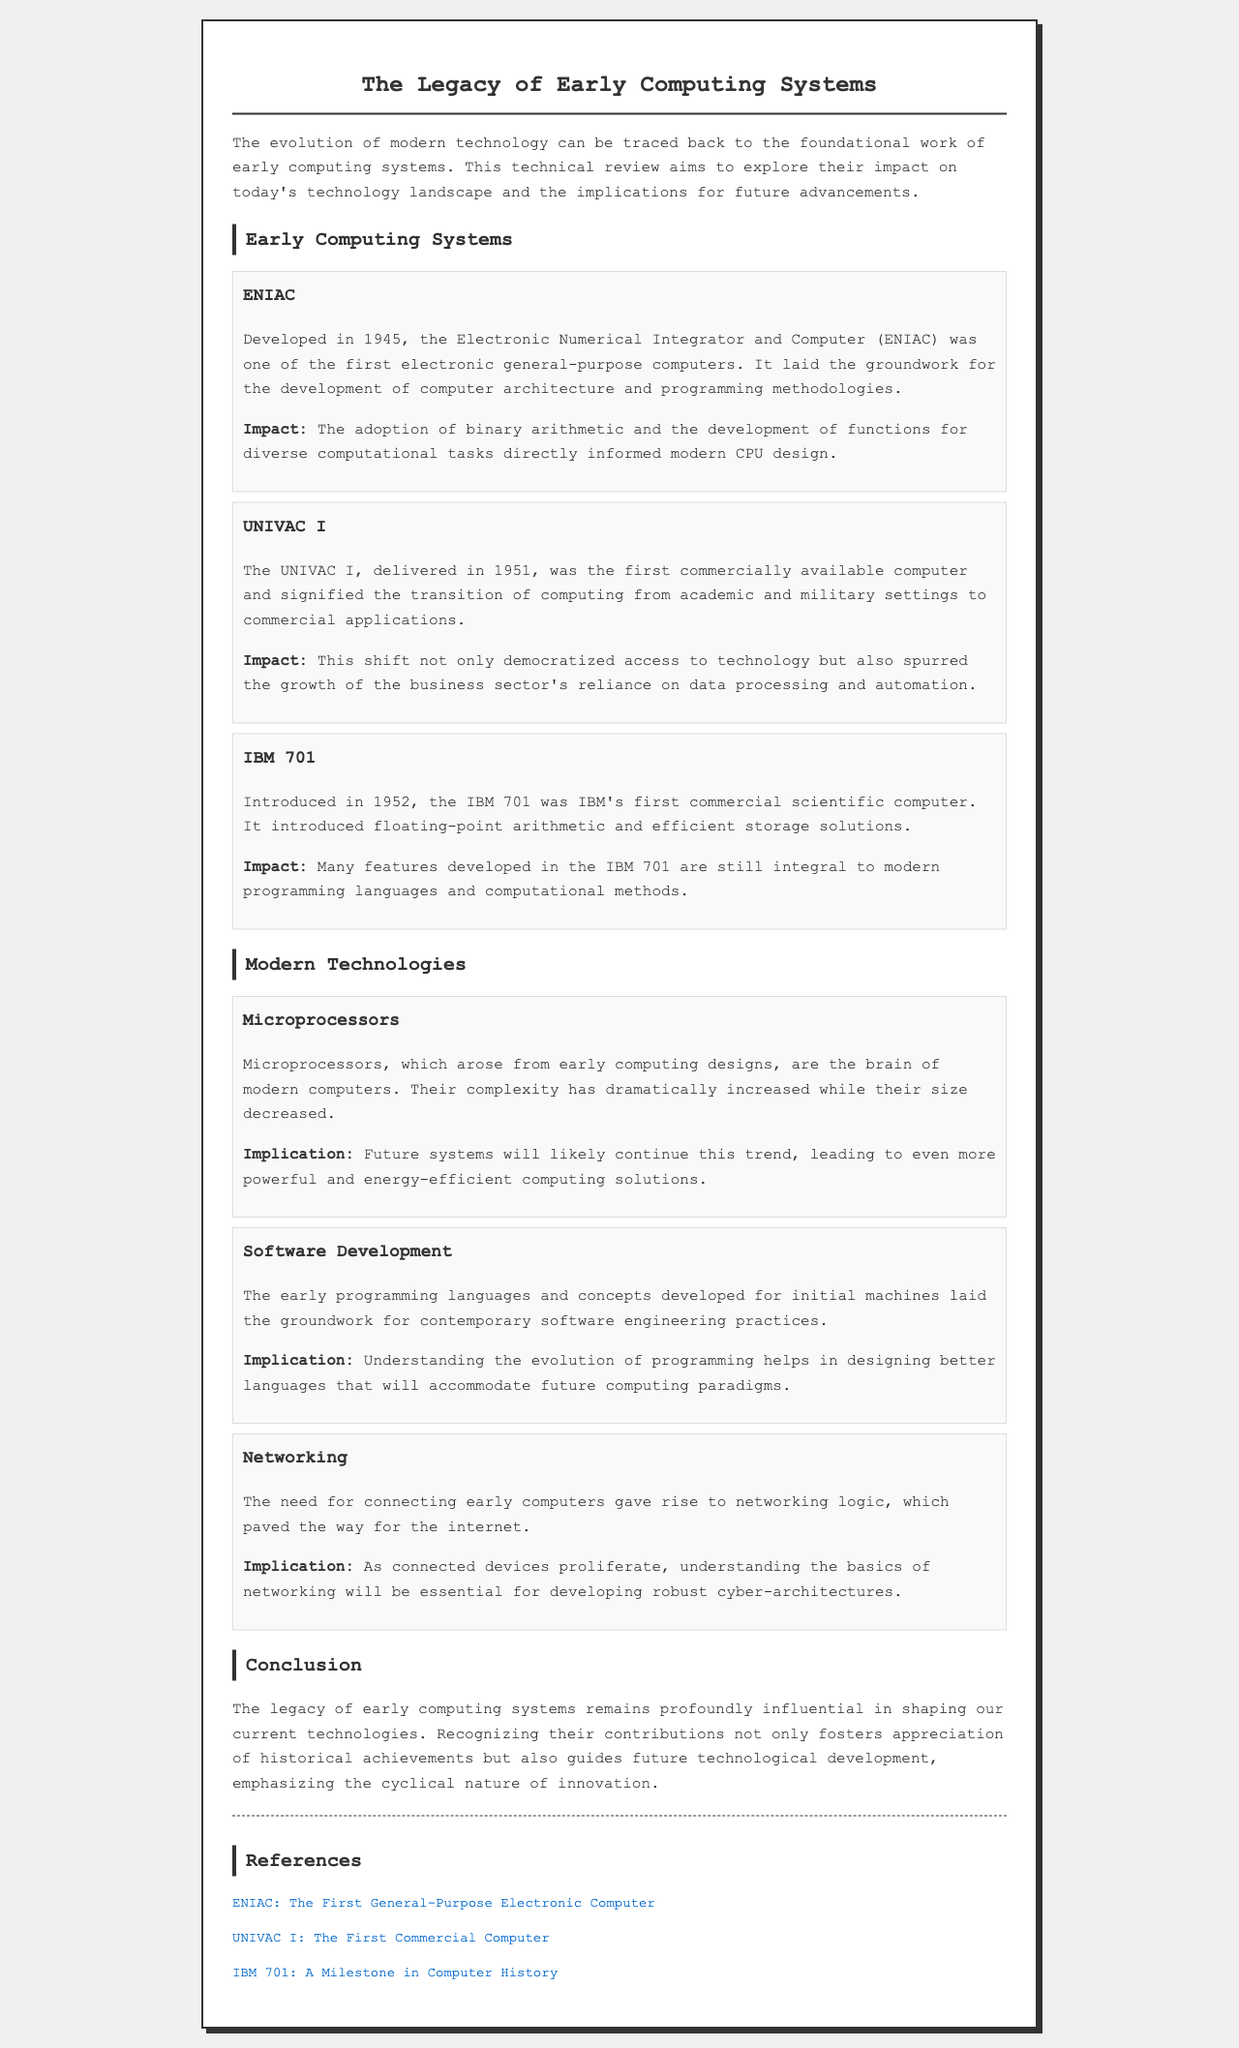what year was ENIAC developed? The document states that ENIAC was developed in 1945.
Answer: 1945 what was the first commercially available computer? The document identifies the UNIVAC I as the first commercially available computer.
Answer: UNIVAC I which arithmetic method was introduced by the IBM 701? The IBM 701 introduced floating-point arithmetic according to the document.
Answer: floating-point arithmetic what is a modern technology that microprocessors evolved from? The document mentions that microprocessors arose from early computing designs.
Answer: early computing designs what is one implication of the evolution of programming languages? The document highlights that understanding their evolution helps in designing better languages for future paradigms.
Answer: designing better languages what distinguishes the need for networking in early computers? The document explains that the need for connecting early computers gave rise to networking logic, paving the way for the internet.
Answer: connecting early computers what is emphasized at the conclusion of the document? The conclusion emphasizes the cyclical nature of innovation and the legacy of early computing systems on modern technologies.
Answer: cyclical nature of innovation what programming concept was necessary for the development of modern software engineering? Early programming languages and concepts were fundamental for contemporary software engineering practices.
Answer: early programming languages and concepts 